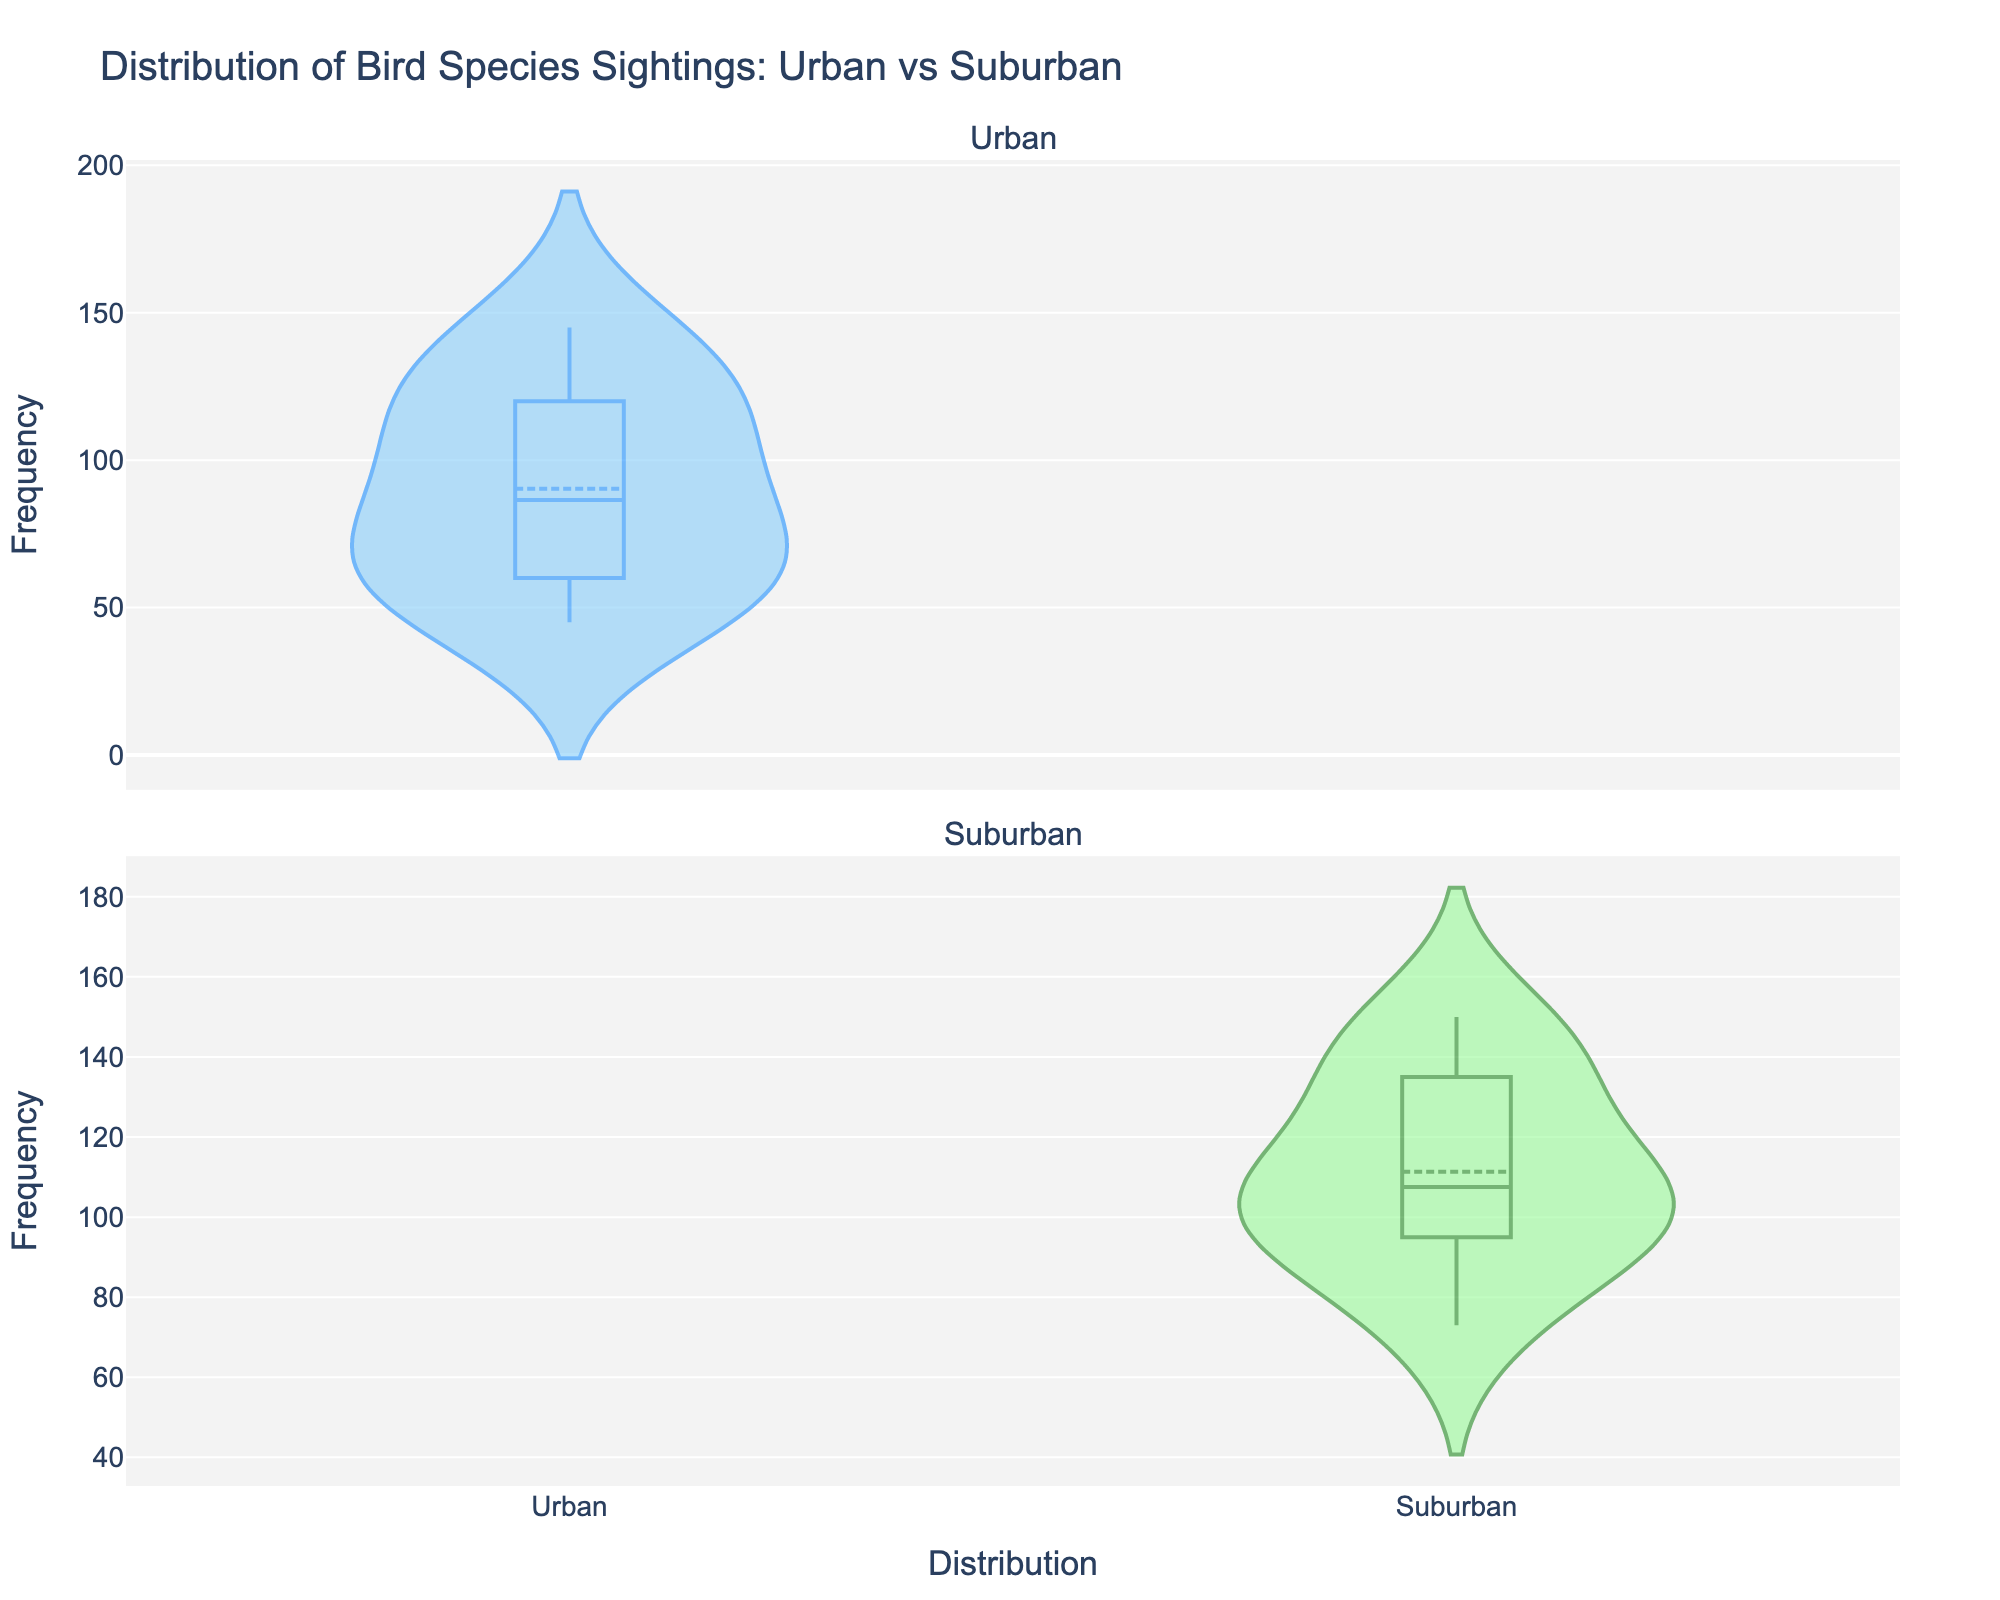what is the title of the plot? The title is displayed at the top of the figure.
Answer: Distribution of Bird Species Sightings: Urban vs Suburban what is the y-axis label for both subplots? The y-axis labels are both visible on the left side of each subplot, indicating the same measurement.
Answer: Frequency What is the maximum frequency of bird sightings in urban areas? From the violin plot for urban areas, the top value on the Y-axis shows the highest frequency.
Answer: 145 What is the interquartile range (IQR) of bird sightings in suburban areas? The IQR is the range between the 25th and 75th percentiles and can be seen in the width of the central part of the violin plot for suburban areas.
Answer: Approximately from 95 to 135 How do the median bird sightings compare between urban and suburban areas? The median is represented by the horizontal line in the box part of each violin plot. Compare the positions of these lines in both subplots.
Answer: The median in suburban areas is higher What is the mean frequency of bird sightings in urban areas? Refer to the meanline visible in the violin plot for urban areas, typically indicated by a different line style or color than the median.
Answer: Approximately 90-100 Which area has a wider distribution of bird sightings, urban or suburban? Compare the spread of the data in both violin plots from the smallest to largest values along the y-axis.
Answer: Suburban Are there more bird sightings in general in urban or suburban areas? Look at the data spread and the central tendency (mean or median) for both urban and suburban plots.
Answer: More in suburban areas What color represents the suburban area in the plot? The legend or the plot coloring directly can indicate which color is used for suburban.
Answer: Green Is there an overlap in the interquartile ranges of bird sightings between urban and suburban areas? Examine the central box areas of both violin plots to see if they overlap on the y-axis.
Answer: Yes 